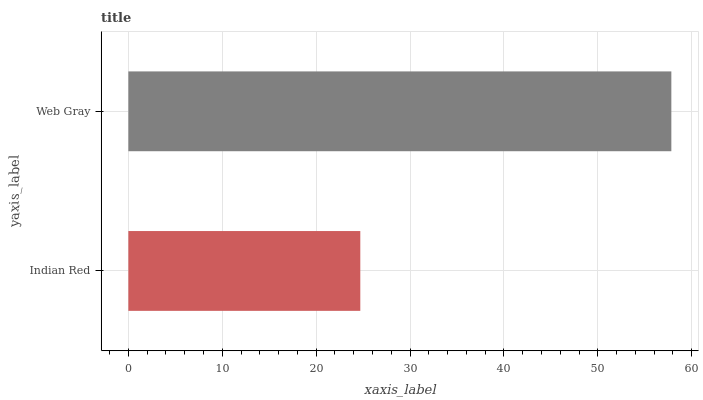Is Indian Red the minimum?
Answer yes or no. Yes. Is Web Gray the maximum?
Answer yes or no. Yes. Is Web Gray the minimum?
Answer yes or no. No. Is Web Gray greater than Indian Red?
Answer yes or no. Yes. Is Indian Red less than Web Gray?
Answer yes or no. Yes. Is Indian Red greater than Web Gray?
Answer yes or no. No. Is Web Gray less than Indian Red?
Answer yes or no. No. Is Web Gray the high median?
Answer yes or no. Yes. Is Indian Red the low median?
Answer yes or no. Yes. Is Indian Red the high median?
Answer yes or no. No. Is Web Gray the low median?
Answer yes or no. No. 